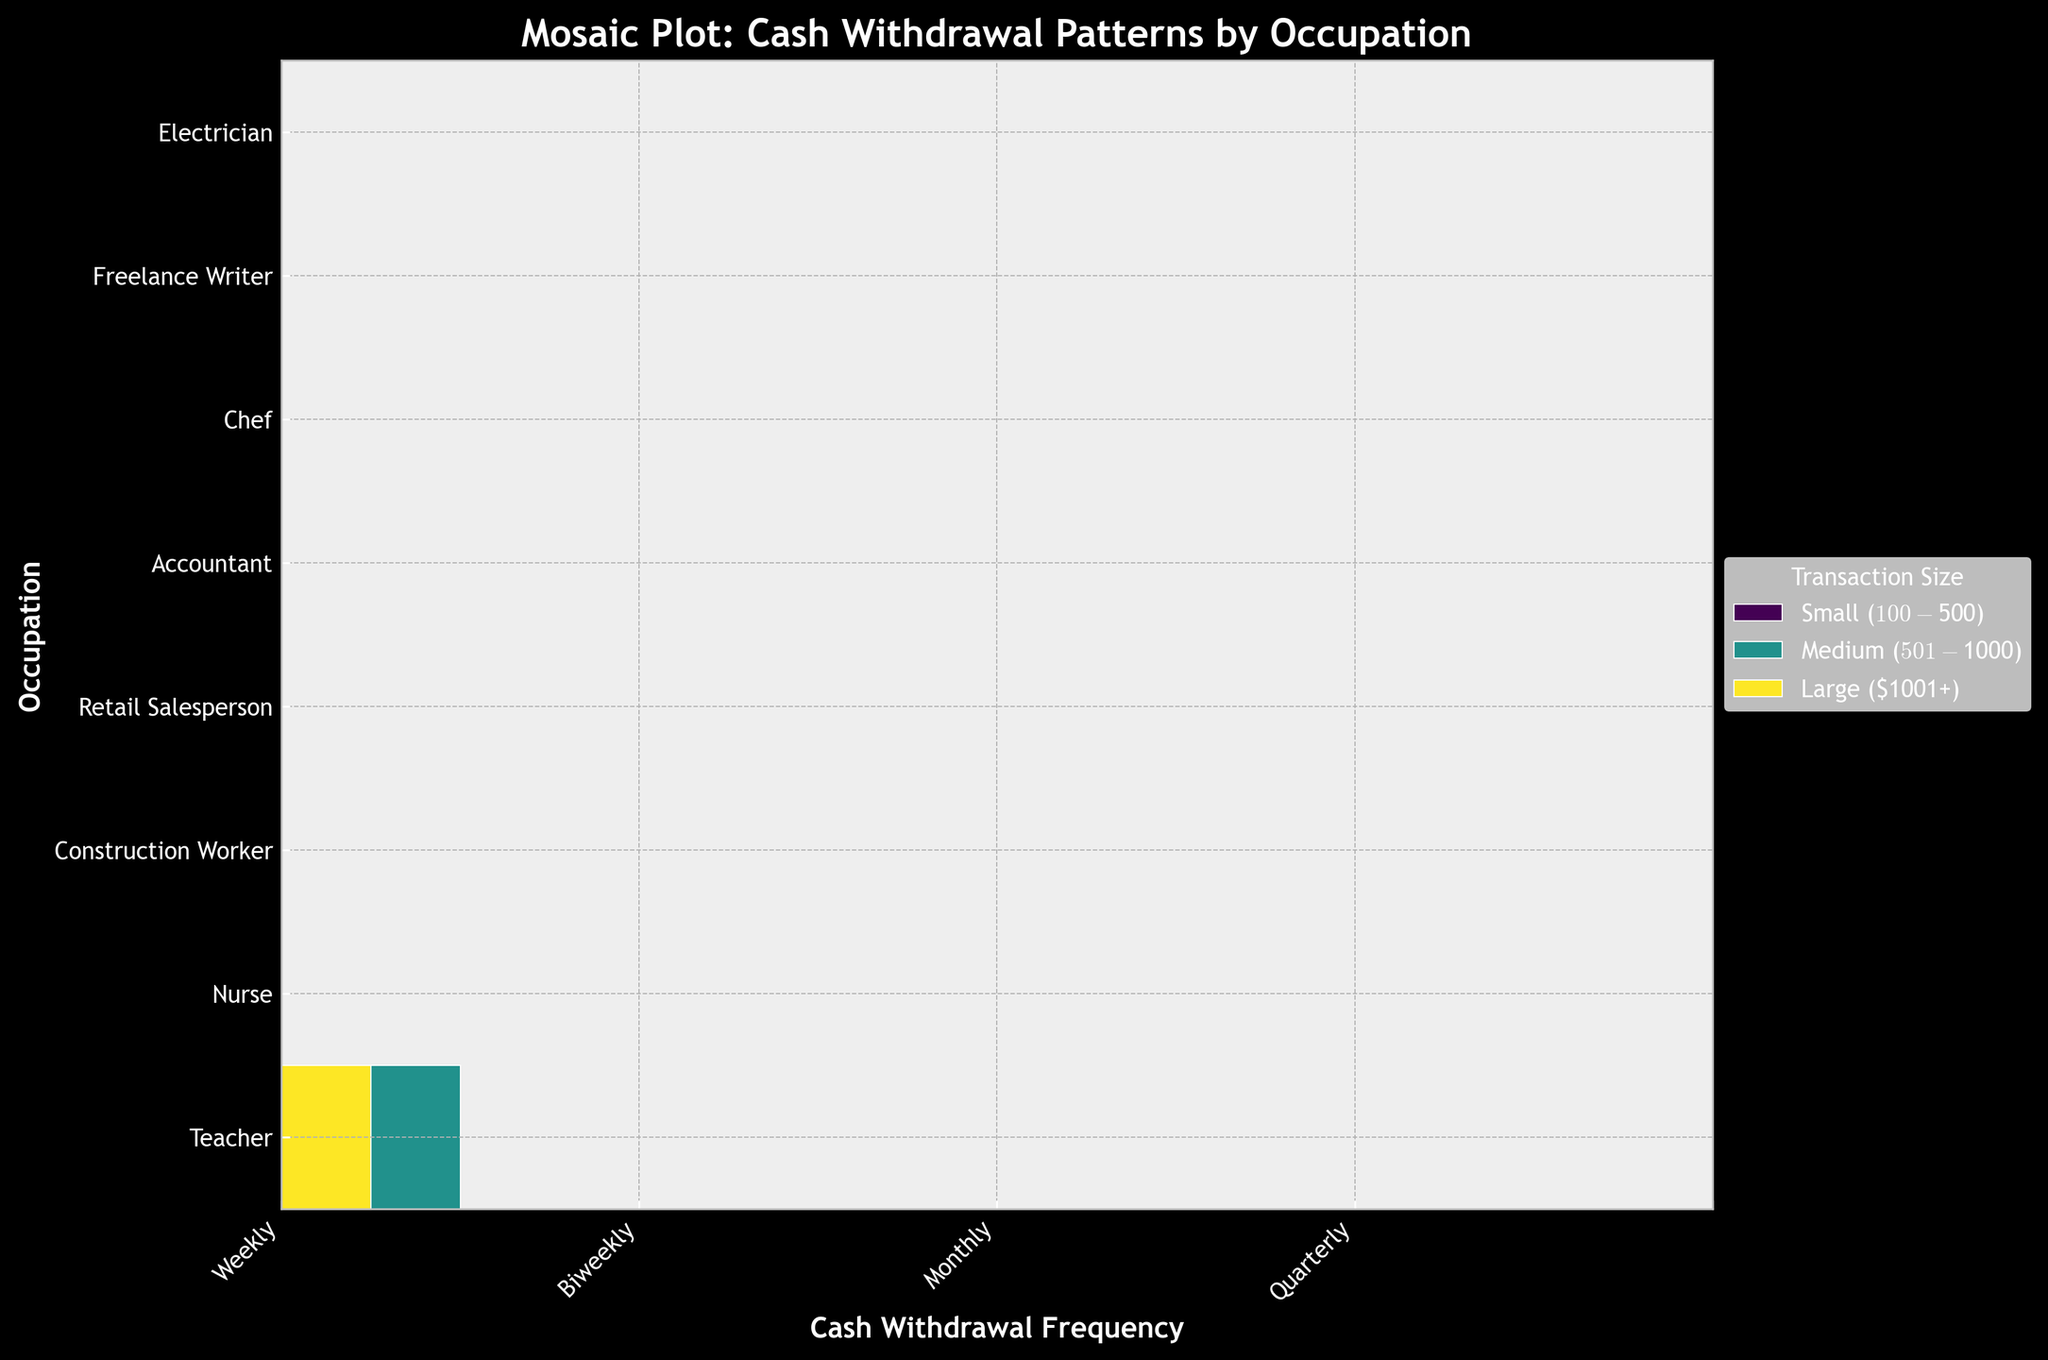What is the title of this plot? The title of a plot is generally located at the top of the figure. In this case, it reads "Mosaic Plot: Cash Withdrawal Patterns by Occupation".
Answer: Mosaic Plot: Cash Withdrawal Patterns by Occupation How many occupations are displayed in the figure? Look at the y-axis labels, which correspond to the different occupations. Count the number of unique labels.
Answer: 8 How is the transaction size represented in the plot? Transaction sizes are represented using colors. There are different shades indicating different categories within the 'Transaction Size'. The legend on the right explains this as Small ($100-$500), Medium ($501-$1000), and Large ($1001+).
Answer: Colors Which occupation has the most frequent weekly cash withdrawals? Look at the rectangles corresponding to the 'Weekly' cash withdrawals on the x-axis and compare their sizes across various occupations on the y-axis. The largest rectangle will indicate the most frequent.
Answer: Retail Salesperson Among the occupations listed, which one has the highest frequency of large transactions? Identify the color representing 'Large ($1001+)' transactions, which is indicated by the darkest color in the legend. Compare the areas of this color across all occupations.
Answer: Construction Worker Which occupation has the smallest proportion of small transactions? Identify the color representing 'Small ($100-$500)', which is indicated by the lightest color in the legend. Compare the areas of this color across all occupations and select the smallest one.
Answer: Accountant How often do nurses withdraw medium-sized amounts? Locate the occupation 'Nurse' on the y-axis. Then, check the areas that are colored for 'Medium ($501-$1000)' to find their frequency on the x-axis.
Answer: Biweekly Which cash withdrawal frequency is most popular among accountants? Locate the occupation 'Accountant' on the y-axis and check the x-axis for the frequency that has the largest area or width.
Answer: Monthly Compare the cash withdrawal frequency between chefs and freelance writers. Which group has a more even distribution across transaction sizes? First, look at the rectangles for 'Chef' and check the sizes for each frequency on the x-axis. Then, do the same for 'Freelance Writer'. Compare the evenness of the distribution of the rectangle areas.
Answer: Freelance Writer How many different transaction sizes are there for cash withdrawals? Look at the legend which categorizes transaction sizes. Count the number of unique colors.
Answer: 3 